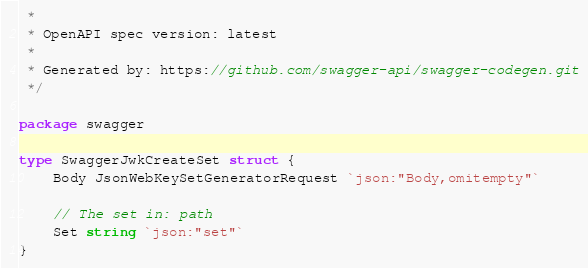Convert code to text. <code><loc_0><loc_0><loc_500><loc_500><_Go_> *
 * OpenAPI spec version: latest
 *
 * Generated by: https://github.com/swagger-api/swagger-codegen.git
 */

package swagger

type SwaggerJwkCreateSet struct {
	Body JsonWebKeySetGeneratorRequest `json:"Body,omitempty"`

	// The set in: path
	Set string `json:"set"`
}
</code> 